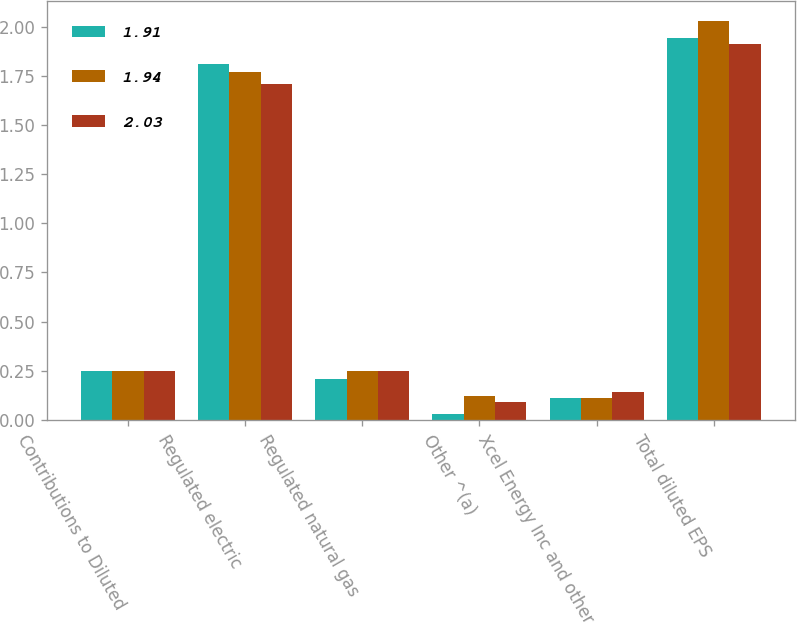Convert chart to OTSL. <chart><loc_0><loc_0><loc_500><loc_500><stacked_bar_chart><ecel><fcel>Contributions to Diluted<fcel>Regulated electric<fcel>Regulated natural gas<fcel>Other ^(a)<fcel>Xcel Energy Inc and other<fcel>Total diluted EPS<nl><fcel>1.91<fcel>0.25<fcel>1.81<fcel>0.21<fcel>0.03<fcel>0.11<fcel>1.94<nl><fcel>1.94<fcel>0.25<fcel>1.77<fcel>0.25<fcel>0.12<fcel>0.11<fcel>2.03<nl><fcel>2.03<fcel>0.25<fcel>1.71<fcel>0.25<fcel>0.09<fcel>0.14<fcel>1.91<nl></chart> 